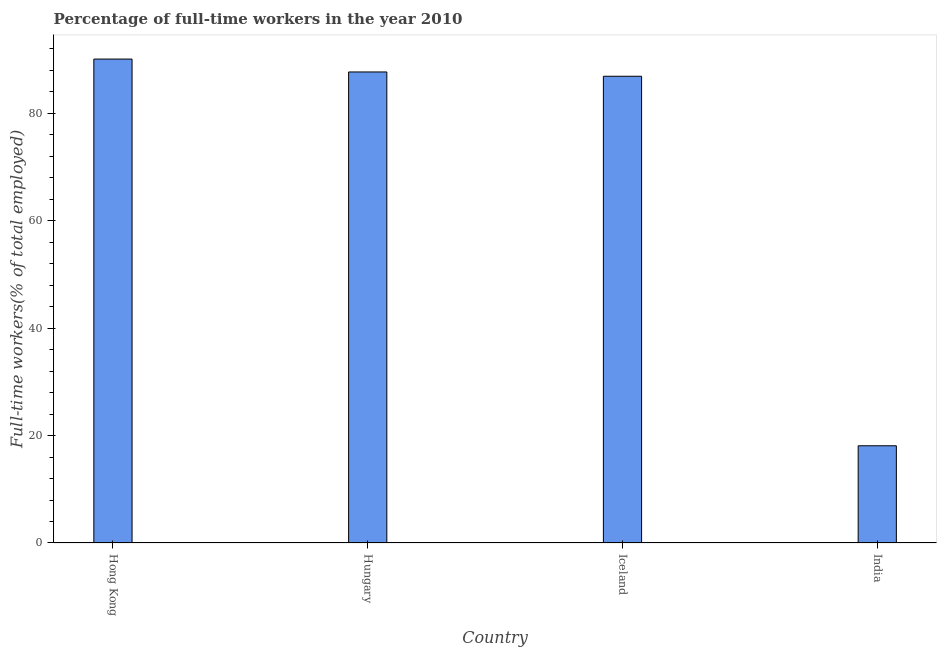Does the graph contain any zero values?
Your answer should be very brief. No. What is the title of the graph?
Give a very brief answer. Percentage of full-time workers in the year 2010. What is the label or title of the Y-axis?
Keep it short and to the point. Full-time workers(% of total employed). What is the percentage of full-time workers in India?
Your answer should be very brief. 18.1. Across all countries, what is the maximum percentage of full-time workers?
Give a very brief answer. 90.1. Across all countries, what is the minimum percentage of full-time workers?
Provide a succinct answer. 18.1. In which country was the percentage of full-time workers maximum?
Provide a succinct answer. Hong Kong. What is the sum of the percentage of full-time workers?
Give a very brief answer. 282.8. What is the difference between the percentage of full-time workers in Hong Kong and India?
Offer a terse response. 72. What is the average percentage of full-time workers per country?
Your answer should be compact. 70.7. What is the median percentage of full-time workers?
Make the answer very short. 87.3. Is the percentage of full-time workers in Iceland less than that in India?
Your response must be concise. No. Is the difference between the percentage of full-time workers in Hungary and Iceland greater than the difference between any two countries?
Keep it short and to the point. No. What is the difference between the highest and the second highest percentage of full-time workers?
Make the answer very short. 2.4. Is the sum of the percentage of full-time workers in Hong Kong and Iceland greater than the maximum percentage of full-time workers across all countries?
Offer a terse response. Yes. Are all the bars in the graph horizontal?
Give a very brief answer. No. Are the values on the major ticks of Y-axis written in scientific E-notation?
Give a very brief answer. No. What is the Full-time workers(% of total employed) in Hong Kong?
Make the answer very short. 90.1. What is the Full-time workers(% of total employed) in Hungary?
Keep it short and to the point. 87.7. What is the Full-time workers(% of total employed) of Iceland?
Your answer should be very brief. 86.9. What is the Full-time workers(% of total employed) in India?
Provide a succinct answer. 18.1. What is the difference between the Full-time workers(% of total employed) in Hong Kong and Hungary?
Keep it short and to the point. 2.4. What is the difference between the Full-time workers(% of total employed) in Hong Kong and India?
Provide a short and direct response. 72. What is the difference between the Full-time workers(% of total employed) in Hungary and Iceland?
Give a very brief answer. 0.8. What is the difference between the Full-time workers(% of total employed) in Hungary and India?
Provide a succinct answer. 69.6. What is the difference between the Full-time workers(% of total employed) in Iceland and India?
Ensure brevity in your answer.  68.8. What is the ratio of the Full-time workers(% of total employed) in Hong Kong to that in Hungary?
Your answer should be compact. 1.03. What is the ratio of the Full-time workers(% of total employed) in Hong Kong to that in Iceland?
Your answer should be very brief. 1.04. What is the ratio of the Full-time workers(% of total employed) in Hong Kong to that in India?
Give a very brief answer. 4.98. What is the ratio of the Full-time workers(% of total employed) in Hungary to that in Iceland?
Offer a terse response. 1.01. What is the ratio of the Full-time workers(% of total employed) in Hungary to that in India?
Keep it short and to the point. 4.84. What is the ratio of the Full-time workers(% of total employed) in Iceland to that in India?
Your response must be concise. 4.8. 